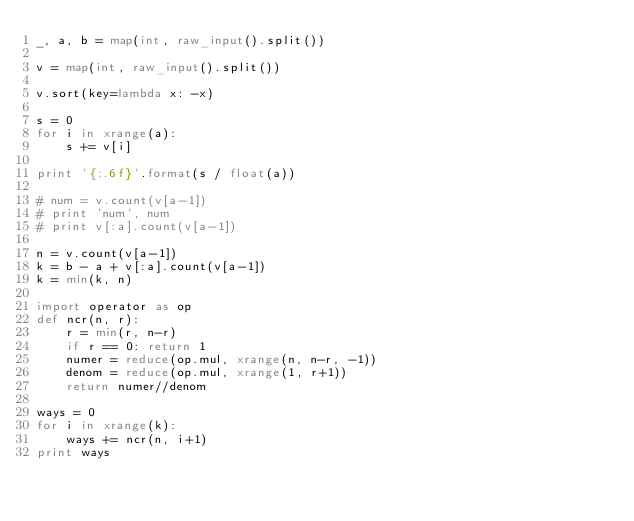<code> <loc_0><loc_0><loc_500><loc_500><_Python_>_, a, b = map(int, raw_input().split())

v = map(int, raw_input().split())

v.sort(key=lambda x: -x)

s = 0
for i in xrange(a):
    s += v[i]

print '{:.6f}'.format(s / float(a))

# num = v.count(v[a-1])
# print 'num', num
# print v[:a].count(v[a-1])

n = v.count(v[a-1])
k = b - a + v[:a].count(v[a-1])
k = min(k, n)

import operator as op
def ncr(n, r):
    r = min(r, n-r)
    if r == 0: return 1
    numer = reduce(op.mul, xrange(n, n-r, -1))
    denom = reduce(op.mul, xrange(1, r+1))
    return numer//denom

ways = 0
for i in xrange(k):
    ways += ncr(n, i+1)
print ways</code> 